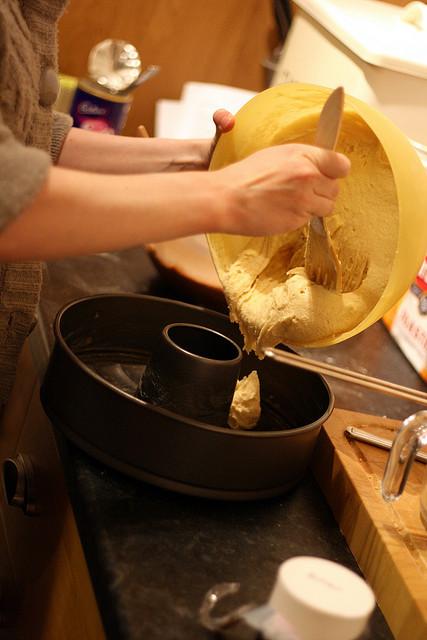What type of cake pan is the person using?
Short answer required. Bundt. Is the person using a fork to put the dough into the cake pan?
Answer briefly. Yes. What is this person making?
Be succinct. Cake. 